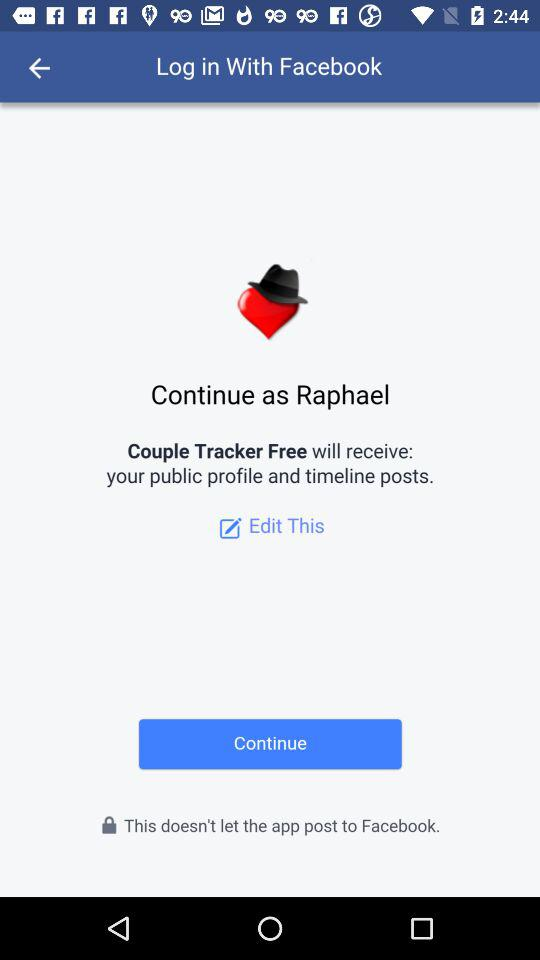What application is asking for permission? The application that is asking for permission is "Couple Tracker Free". 